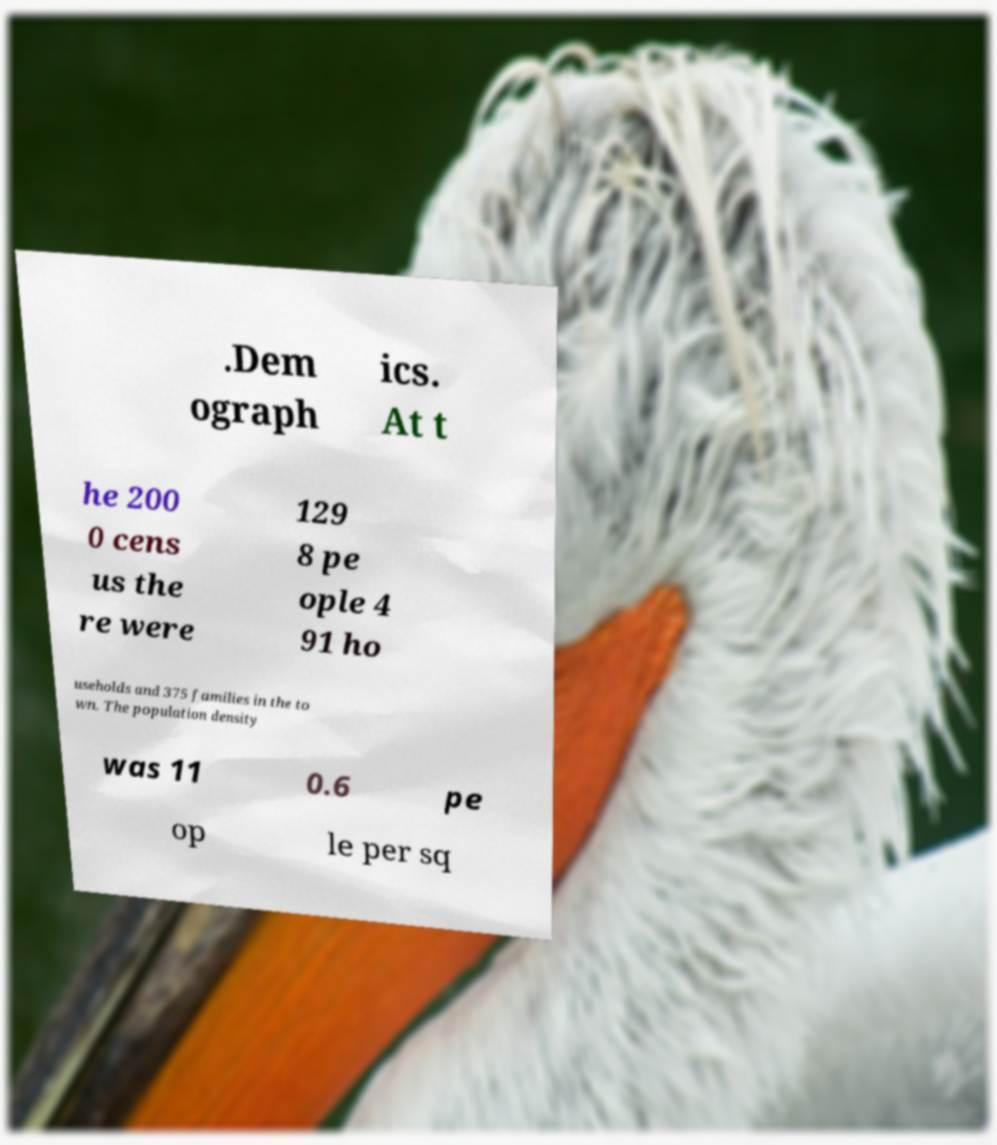I need the written content from this picture converted into text. Can you do that? .Dem ograph ics. At t he 200 0 cens us the re were 129 8 pe ople 4 91 ho useholds and 375 families in the to wn. The population density was 11 0.6 pe op le per sq 